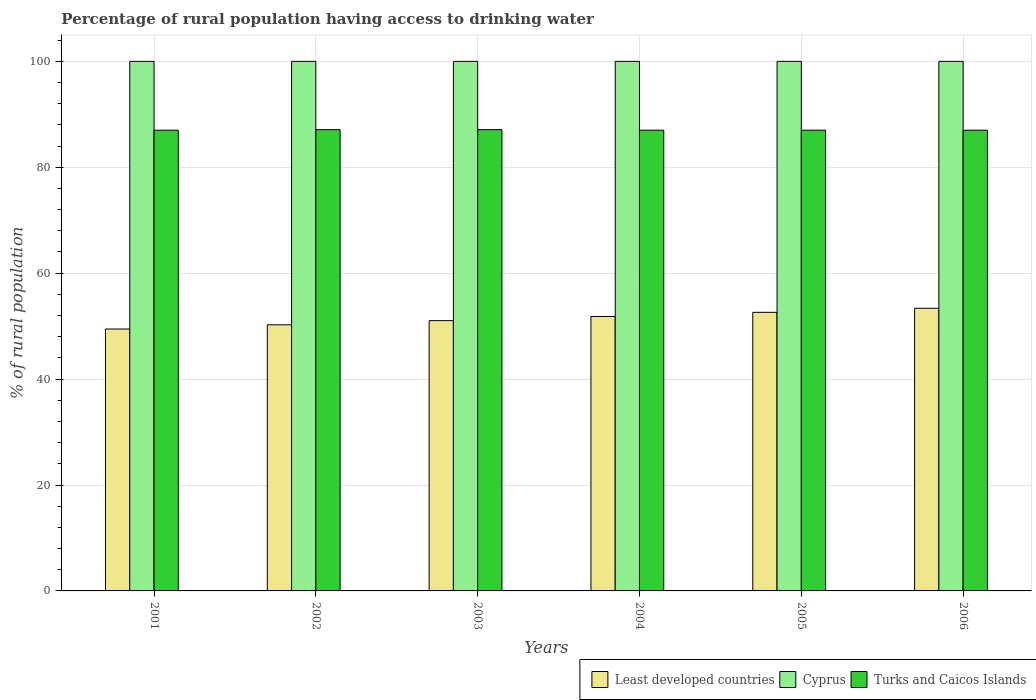Are the number of bars per tick equal to the number of legend labels?
Your response must be concise. Yes. Are the number of bars on each tick of the X-axis equal?
Your answer should be compact. Yes. How many bars are there on the 1st tick from the left?
Offer a terse response. 3. How many bars are there on the 5th tick from the right?
Your answer should be compact. 3. What is the label of the 5th group of bars from the left?
Make the answer very short. 2005. In how many cases, is the number of bars for a given year not equal to the number of legend labels?
Give a very brief answer. 0. What is the percentage of rural population having access to drinking water in Cyprus in 2004?
Your answer should be compact. 100. Across all years, what is the maximum percentage of rural population having access to drinking water in Cyprus?
Your response must be concise. 100. Across all years, what is the minimum percentage of rural population having access to drinking water in Least developed countries?
Give a very brief answer. 49.46. What is the total percentage of rural population having access to drinking water in Turks and Caicos Islands in the graph?
Your answer should be very brief. 522.2. What is the difference between the percentage of rural population having access to drinking water in Least developed countries in 2003 and that in 2005?
Offer a terse response. -1.57. What is the difference between the percentage of rural population having access to drinking water in Cyprus in 2005 and the percentage of rural population having access to drinking water in Least developed countries in 2004?
Give a very brief answer. 48.18. In the year 2002, what is the difference between the percentage of rural population having access to drinking water in Cyprus and percentage of rural population having access to drinking water in Turks and Caicos Islands?
Offer a very short reply. 12.9. In how many years, is the percentage of rural population having access to drinking water in Cyprus greater than 60 %?
Make the answer very short. 6. What is the ratio of the percentage of rural population having access to drinking water in Cyprus in 2003 to that in 2005?
Provide a short and direct response. 1. What is the difference between the highest and the second highest percentage of rural population having access to drinking water in Least developed countries?
Offer a very short reply. 0.77. What is the difference between the highest and the lowest percentage of rural population having access to drinking water in Least developed countries?
Offer a terse response. 3.92. Is the sum of the percentage of rural population having access to drinking water in Least developed countries in 2003 and 2005 greater than the maximum percentage of rural population having access to drinking water in Turks and Caicos Islands across all years?
Offer a very short reply. Yes. What does the 3rd bar from the left in 2004 represents?
Offer a terse response. Turks and Caicos Islands. What does the 1st bar from the right in 2005 represents?
Your answer should be very brief. Turks and Caicos Islands. How many bars are there?
Make the answer very short. 18. Are all the bars in the graph horizontal?
Give a very brief answer. No. How many years are there in the graph?
Give a very brief answer. 6. Does the graph contain any zero values?
Ensure brevity in your answer.  No. Does the graph contain grids?
Your answer should be very brief. Yes. Where does the legend appear in the graph?
Offer a terse response. Bottom right. What is the title of the graph?
Offer a very short reply. Percentage of rural population having access to drinking water. What is the label or title of the X-axis?
Offer a terse response. Years. What is the label or title of the Y-axis?
Offer a very short reply. % of rural population. What is the % of rural population in Least developed countries in 2001?
Give a very brief answer. 49.46. What is the % of rural population of Cyprus in 2001?
Provide a short and direct response. 100. What is the % of rural population in Least developed countries in 2002?
Offer a terse response. 50.25. What is the % of rural population of Turks and Caicos Islands in 2002?
Your answer should be very brief. 87.1. What is the % of rural population of Least developed countries in 2003?
Provide a succinct answer. 51.04. What is the % of rural population of Turks and Caicos Islands in 2003?
Ensure brevity in your answer.  87.1. What is the % of rural population of Least developed countries in 2004?
Your answer should be very brief. 51.82. What is the % of rural population in Cyprus in 2004?
Ensure brevity in your answer.  100. What is the % of rural population of Turks and Caicos Islands in 2004?
Provide a succinct answer. 87. What is the % of rural population of Least developed countries in 2005?
Your response must be concise. 52.61. What is the % of rural population in Least developed countries in 2006?
Offer a very short reply. 53.38. Across all years, what is the maximum % of rural population of Least developed countries?
Keep it short and to the point. 53.38. Across all years, what is the maximum % of rural population of Cyprus?
Your answer should be very brief. 100. Across all years, what is the maximum % of rural population in Turks and Caicos Islands?
Give a very brief answer. 87.1. Across all years, what is the minimum % of rural population in Least developed countries?
Provide a succinct answer. 49.46. Across all years, what is the minimum % of rural population in Cyprus?
Ensure brevity in your answer.  100. What is the total % of rural population of Least developed countries in the graph?
Keep it short and to the point. 308.56. What is the total % of rural population of Cyprus in the graph?
Your response must be concise. 600. What is the total % of rural population in Turks and Caicos Islands in the graph?
Make the answer very short. 522.2. What is the difference between the % of rural population in Least developed countries in 2001 and that in 2002?
Offer a terse response. -0.8. What is the difference between the % of rural population in Cyprus in 2001 and that in 2002?
Provide a short and direct response. 0. What is the difference between the % of rural population of Least developed countries in 2001 and that in 2003?
Make the answer very short. -1.58. What is the difference between the % of rural population of Cyprus in 2001 and that in 2003?
Give a very brief answer. 0. What is the difference between the % of rural population in Least developed countries in 2001 and that in 2004?
Provide a short and direct response. -2.36. What is the difference between the % of rural population in Cyprus in 2001 and that in 2004?
Give a very brief answer. 0. What is the difference between the % of rural population of Turks and Caicos Islands in 2001 and that in 2004?
Provide a short and direct response. 0. What is the difference between the % of rural population of Least developed countries in 2001 and that in 2005?
Keep it short and to the point. -3.15. What is the difference between the % of rural population of Least developed countries in 2001 and that in 2006?
Keep it short and to the point. -3.92. What is the difference between the % of rural population in Cyprus in 2001 and that in 2006?
Provide a succinct answer. 0. What is the difference between the % of rural population of Turks and Caicos Islands in 2001 and that in 2006?
Provide a short and direct response. 0. What is the difference between the % of rural population of Least developed countries in 2002 and that in 2003?
Provide a succinct answer. -0.78. What is the difference between the % of rural population of Turks and Caicos Islands in 2002 and that in 2003?
Offer a very short reply. 0. What is the difference between the % of rural population in Least developed countries in 2002 and that in 2004?
Keep it short and to the point. -1.57. What is the difference between the % of rural population in Cyprus in 2002 and that in 2004?
Provide a succinct answer. 0. What is the difference between the % of rural population of Least developed countries in 2002 and that in 2005?
Your answer should be very brief. -2.35. What is the difference between the % of rural population of Cyprus in 2002 and that in 2005?
Your answer should be very brief. 0. What is the difference between the % of rural population in Least developed countries in 2002 and that in 2006?
Your answer should be compact. -3.12. What is the difference between the % of rural population of Cyprus in 2002 and that in 2006?
Make the answer very short. 0. What is the difference between the % of rural population of Turks and Caicos Islands in 2002 and that in 2006?
Keep it short and to the point. 0.1. What is the difference between the % of rural population in Least developed countries in 2003 and that in 2004?
Provide a short and direct response. -0.78. What is the difference between the % of rural population of Turks and Caicos Islands in 2003 and that in 2004?
Offer a very short reply. 0.1. What is the difference between the % of rural population of Least developed countries in 2003 and that in 2005?
Make the answer very short. -1.57. What is the difference between the % of rural population in Least developed countries in 2003 and that in 2006?
Offer a very short reply. -2.34. What is the difference between the % of rural population in Cyprus in 2003 and that in 2006?
Provide a short and direct response. 0. What is the difference between the % of rural population in Turks and Caicos Islands in 2003 and that in 2006?
Provide a short and direct response. 0.1. What is the difference between the % of rural population of Least developed countries in 2004 and that in 2005?
Provide a succinct answer. -0.79. What is the difference between the % of rural population of Cyprus in 2004 and that in 2005?
Your answer should be very brief. 0. What is the difference between the % of rural population of Turks and Caicos Islands in 2004 and that in 2005?
Offer a terse response. 0. What is the difference between the % of rural population in Least developed countries in 2004 and that in 2006?
Offer a terse response. -1.56. What is the difference between the % of rural population of Cyprus in 2004 and that in 2006?
Your answer should be very brief. 0. What is the difference between the % of rural population of Least developed countries in 2005 and that in 2006?
Keep it short and to the point. -0.77. What is the difference between the % of rural population of Cyprus in 2005 and that in 2006?
Ensure brevity in your answer.  0. What is the difference between the % of rural population in Least developed countries in 2001 and the % of rural population in Cyprus in 2002?
Offer a very short reply. -50.54. What is the difference between the % of rural population in Least developed countries in 2001 and the % of rural population in Turks and Caicos Islands in 2002?
Offer a very short reply. -37.64. What is the difference between the % of rural population of Cyprus in 2001 and the % of rural population of Turks and Caicos Islands in 2002?
Make the answer very short. 12.9. What is the difference between the % of rural population of Least developed countries in 2001 and the % of rural population of Cyprus in 2003?
Keep it short and to the point. -50.54. What is the difference between the % of rural population in Least developed countries in 2001 and the % of rural population in Turks and Caicos Islands in 2003?
Your answer should be compact. -37.64. What is the difference between the % of rural population of Least developed countries in 2001 and the % of rural population of Cyprus in 2004?
Your answer should be compact. -50.54. What is the difference between the % of rural population in Least developed countries in 2001 and the % of rural population in Turks and Caicos Islands in 2004?
Provide a short and direct response. -37.54. What is the difference between the % of rural population in Least developed countries in 2001 and the % of rural population in Cyprus in 2005?
Provide a short and direct response. -50.54. What is the difference between the % of rural population in Least developed countries in 2001 and the % of rural population in Turks and Caicos Islands in 2005?
Provide a short and direct response. -37.54. What is the difference between the % of rural population in Least developed countries in 2001 and the % of rural population in Cyprus in 2006?
Offer a very short reply. -50.54. What is the difference between the % of rural population in Least developed countries in 2001 and the % of rural population in Turks and Caicos Islands in 2006?
Offer a very short reply. -37.54. What is the difference between the % of rural population of Least developed countries in 2002 and the % of rural population of Cyprus in 2003?
Offer a terse response. -49.74. What is the difference between the % of rural population in Least developed countries in 2002 and the % of rural population in Turks and Caicos Islands in 2003?
Your answer should be very brief. -36.84. What is the difference between the % of rural population in Cyprus in 2002 and the % of rural population in Turks and Caicos Islands in 2003?
Give a very brief answer. 12.9. What is the difference between the % of rural population of Least developed countries in 2002 and the % of rural population of Cyprus in 2004?
Offer a very short reply. -49.74. What is the difference between the % of rural population of Least developed countries in 2002 and the % of rural population of Turks and Caicos Islands in 2004?
Offer a terse response. -36.74. What is the difference between the % of rural population in Cyprus in 2002 and the % of rural population in Turks and Caicos Islands in 2004?
Make the answer very short. 13. What is the difference between the % of rural population in Least developed countries in 2002 and the % of rural population in Cyprus in 2005?
Offer a terse response. -49.74. What is the difference between the % of rural population in Least developed countries in 2002 and the % of rural population in Turks and Caicos Islands in 2005?
Give a very brief answer. -36.74. What is the difference between the % of rural population of Least developed countries in 2002 and the % of rural population of Cyprus in 2006?
Offer a terse response. -49.74. What is the difference between the % of rural population in Least developed countries in 2002 and the % of rural population in Turks and Caicos Islands in 2006?
Make the answer very short. -36.74. What is the difference between the % of rural population in Cyprus in 2002 and the % of rural population in Turks and Caicos Islands in 2006?
Make the answer very short. 13. What is the difference between the % of rural population in Least developed countries in 2003 and the % of rural population in Cyprus in 2004?
Give a very brief answer. -48.96. What is the difference between the % of rural population of Least developed countries in 2003 and the % of rural population of Turks and Caicos Islands in 2004?
Offer a very short reply. -35.96. What is the difference between the % of rural population in Cyprus in 2003 and the % of rural population in Turks and Caicos Islands in 2004?
Provide a short and direct response. 13. What is the difference between the % of rural population in Least developed countries in 2003 and the % of rural population in Cyprus in 2005?
Give a very brief answer. -48.96. What is the difference between the % of rural population in Least developed countries in 2003 and the % of rural population in Turks and Caicos Islands in 2005?
Your answer should be compact. -35.96. What is the difference between the % of rural population of Cyprus in 2003 and the % of rural population of Turks and Caicos Islands in 2005?
Offer a terse response. 13. What is the difference between the % of rural population of Least developed countries in 2003 and the % of rural population of Cyprus in 2006?
Ensure brevity in your answer.  -48.96. What is the difference between the % of rural population in Least developed countries in 2003 and the % of rural population in Turks and Caicos Islands in 2006?
Provide a succinct answer. -35.96. What is the difference between the % of rural population in Cyprus in 2003 and the % of rural population in Turks and Caicos Islands in 2006?
Your answer should be very brief. 13. What is the difference between the % of rural population in Least developed countries in 2004 and the % of rural population in Cyprus in 2005?
Give a very brief answer. -48.18. What is the difference between the % of rural population of Least developed countries in 2004 and the % of rural population of Turks and Caicos Islands in 2005?
Make the answer very short. -35.18. What is the difference between the % of rural population in Least developed countries in 2004 and the % of rural population in Cyprus in 2006?
Your response must be concise. -48.18. What is the difference between the % of rural population in Least developed countries in 2004 and the % of rural population in Turks and Caicos Islands in 2006?
Give a very brief answer. -35.18. What is the difference between the % of rural population of Least developed countries in 2005 and the % of rural population of Cyprus in 2006?
Ensure brevity in your answer.  -47.39. What is the difference between the % of rural population in Least developed countries in 2005 and the % of rural population in Turks and Caicos Islands in 2006?
Your answer should be compact. -34.39. What is the difference between the % of rural population in Cyprus in 2005 and the % of rural population in Turks and Caicos Islands in 2006?
Make the answer very short. 13. What is the average % of rural population of Least developed countries per year?
Provide a short and direct response. 51.43. What is the average % of rural population of Cyprus per year?
Your response must be concise. 100. What is the average % of rural population of Turks and Caicos Islands per year?
Offer a very short reply. 87.03. In the year 2001, what is the difference between the % of rural population in Least developed countries and % of rural population in Cyprus?
Offer a terse response. -50.54. In the year 2001, what is the difference between the % of rural population of Least developed countries and % of rural population of Turks and Caicos Islands?
Your answer should be very brief. -37.54. In the year 2002, what is the difference between the % of rural population of Least developed countries and % of rural population of Cyprus?
Ensure brevity in your answer.  -49.74. In the year 2002, what is the difference between the % of rural population of Least developed countries and % of rural population of Turks and Caicos Islands?
Offer a very short reply. -36.84. In the year 2002, what is the difference between the % of rural population in Cyprus and % of rural population in Turks and Caicos Islands?
Your answer should be very brief. 12.9. In the year 2003, what is the difference between the % of rural population of Least developed countries and % of rural population of Cyprus?
Your answer should be compact. -48.96. In the year 2003, what is the difference between the % of rural population in Least developed countries and % of rural population in Turks and Caicos Islands?
Offer a terse response. -36.06. In the year 2004, what is the difference between the % of rural population of Least developed countries and % of rural population of Cyprus?
Provide a short and direct response. -48.18. In the year 2004, what is the difference between the % of rural population in Least developed countries and % of rural population in Turks and Caicos Islands?
Give a very brief answer. -35.18. In the year 2004, what is the difference between the % of rural population of Cyprus and % of rural population of Turks and Caicos Islands?
Ensure brevity in your answer.  13. In the year 2005, what is the difference between the % of rural population in Least developed countries and % of rural population in Cyprus?
Ensure brevity in your answer.  -47.39. In the year 2005, what is the difference between the % of rural population of Least developed countries and % of rural population of Turks and Caicos Islands?
Provide a short and direct response. -34.39. In the year 2006, what is the difference between the % of rural population of Least developed countries and % of rural population of Cyprus?
Ensure brevity in your answer.  -46.62. In the year 2006, what is the difference between the % of rural population of Least developed countries and % of rural population of Turks and Caicos Islands?
Your answer should be compact. -33.62. In the year 2006, what is the difference between the % of rural population in Cyprus and % of rural population in Turks and Caicos Islands?
Keep it short and to the point. 13. What is the ratio of the % of rural population in Least developed countries in 2001 to that in 2002?
Your answer should be compact. 0.98. What is the ratio of the % of rural population in Cyprus in 2001 to that in 2002?
Keep it short and to the point. 1. What is the ratio of the % of rural population of Turks and Caicos Islands in 2001 to that in 2002?
Your response must be concise. 1. What is the ratio of the % of rural population of Least developed countries in 2001 to that in 2003?
Keep it short and to the point. 0.97. What is the ratio of the % of rural population of Cyprus in 2001 to that in 2003?
Offer a terse response. 1. What is the ratio of the % of rural population of Least developed countries in 2001 to that in 2004?
Give a very brief answer. 0.95. What is the ratio of the % of rural population in Cyprus in 2001 to that in 2004?
Give a very brief answer. 1. What is the ratio of the % of rural population in Least developed countries in 2001 to that in 2005?
Your response must be concise. 0.94. What is the ratio of the % of rural population in Cyprus in 2001 to that in 2005?
Keep it short and to the point. 1. What is the ratio of the % of rural population in Turks and Caicos Islands in 2001 to that in 2005?
Provide a succinct answer. 1. What is the ratio of the % of rural population in Least developed countries in 2001 to that in 2006?
Your answer should be very brief. 0.93. What is the ratio of the % of rural population in Cyprus in 2001 to that in 2006?
Your answer should be very brief. 1. What is the ratio of the % of rural population in Least developed countries in 2002 to that in 2003?
Offer a terse response. 0.98. What is the ratio of the % of rural population in Cyprus in 2002 to that in 2003?
Offer a terse response. 1. What is the ratio of the % of rural population in Least developed countries in 2002 to that in 2004?
Offer a terse response. 0.97. What is the ratio of the % of rural population of Cyprus in 2002 to that in 2004?
Offer a terse response. 1. What is the ratio of the % of rural population in Least developed countries in 2002 to that in 2005?
Ensure brevity in your answer.  0.96. What is the ratio of the % of rural population in Cyprus in 2002 to that in 2005?
Make the answer very short. 1. What is the ratio of the % of rural population of Turks and Caicos Islands in 2002 to that in 2005?
Provide a short and direct response. 1. What is the ratio of the % of rural population in Least developed countries in 2002 to that in 2006?
Offer a very short reply. 0.94. What is the ratio of the % of rural population in Cyprus in 2002 to that in 2006?
Offer a terse response. 1. What is the ratio of the % of rural population of Least developed countries in 2003 to that in 2004?
Your response must be concise. 0.98. What is the ratio of the % of rural population in Least developed countries in 2003 to that in 2005?
Give a very brief answer. 0.97. What is the ratio of the % of rural population of Turks and Caicos Islands in 2003 to that in 2005?
Offer a very short reply. 1. What is the ratio of the % of rural population in Least developed countries in 2003 to that in 2006?
Your response must be concise. 0.96. What is the ratio of the % of rural population in Cyprus in 2003 to that in 2006?
Provide a succinct answer. 1. What is the ratio of the % of rural population in Least developed countries in 2004 to that in 2005?
Make the answer very short. 0.99. What is the ratio of the % of rural population in Cyprus in 2004 to that in 2005?
Provide a succinct answer. 1. What is the ratio of the % of rural population in Least developed countries in 2004 to that in 2006?
Your answer should be compact. 0.97. What is the ratio of the % of rural population of Cyprus in 2004 to that in 2006?
Your response must be concise. 1. What is the ratio of the % of rural population of Turks and Caicos Islands in 2004 to that in 2006?
Your answer should be very brief. 1. What is the ratio of the % of rural population in Least developed countries in 2005 to that in 2006?
Offer a terse response. 0.99. What is the ratio of the % of rural population in Cyprus in 2005 to that in 2006?
Make the answer very short. 1. What is the difference between the highest and the second highest % of rural population in Least developed countries?
Your answer should be very brief. 0.77. What is the difference between the highest and the second highest % of rural population in Cyprus?
Make the answer very short. 0. What is the difference between the highest and the second highest % of rural population in Turks and Caicos Islands?
Your answer should be very brief. 0. What is the difference between the highest and the lowest % of rural population in Least developed countries?
Provide a succinct answer. 3.92. What is the difference between the highest and the lowest % of rural population in Cyprus?
Your answer should be compact. 0. 